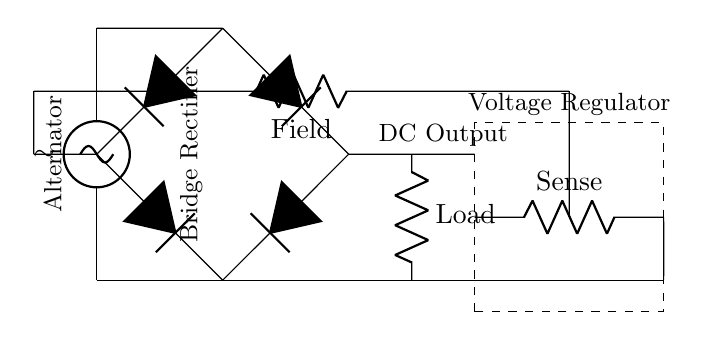What is the type of current produced by the bridge rectifier? The bridge rectifier converts alternating current from the alternator to direct current.
Answer: Direct current What components are used in the bridge rectifier? The bridge rectifier consists of four diodes positioned to allow current flow in a single direction, effectively converting AC to DC.
Answer: Four diodes What is the purpose of the voltage regulator in this circuit? The voltage regulator maintains a constant output voltage to ensure the electrical system does not receive too much or too little voltage, protecting sensitive components.
Answer: Voltage stabilization What is the load in this circuit diagram? The load represents the electrical components that consume the output power from the rectifier, effectively utilizing the generated DC voltage for the vehicle’s operation.
Answer: Load How does the field winding control affect the alternator's output? The field winding control regulates the electromagnetic field within the alternator, adjusting the output voltage based on the demand and maintaining efficiency and stability in the system.
Answer: Output regulation What is the significance of the sense resistor in the voltage regulator? The sense resistor monitors the output voltage and provides feedback to the voltage regulator, allowing it to make adjustments to maintain the desired voltage level in the circuit.
Answer: Feedback mechanism What is the relationship between the alternator and the rectifier in this circuit? The alternator produces alternating current, which the rectifier then converts to direct current for use in the vehicle’s electrical system.
Answer: AC to DC conversion 